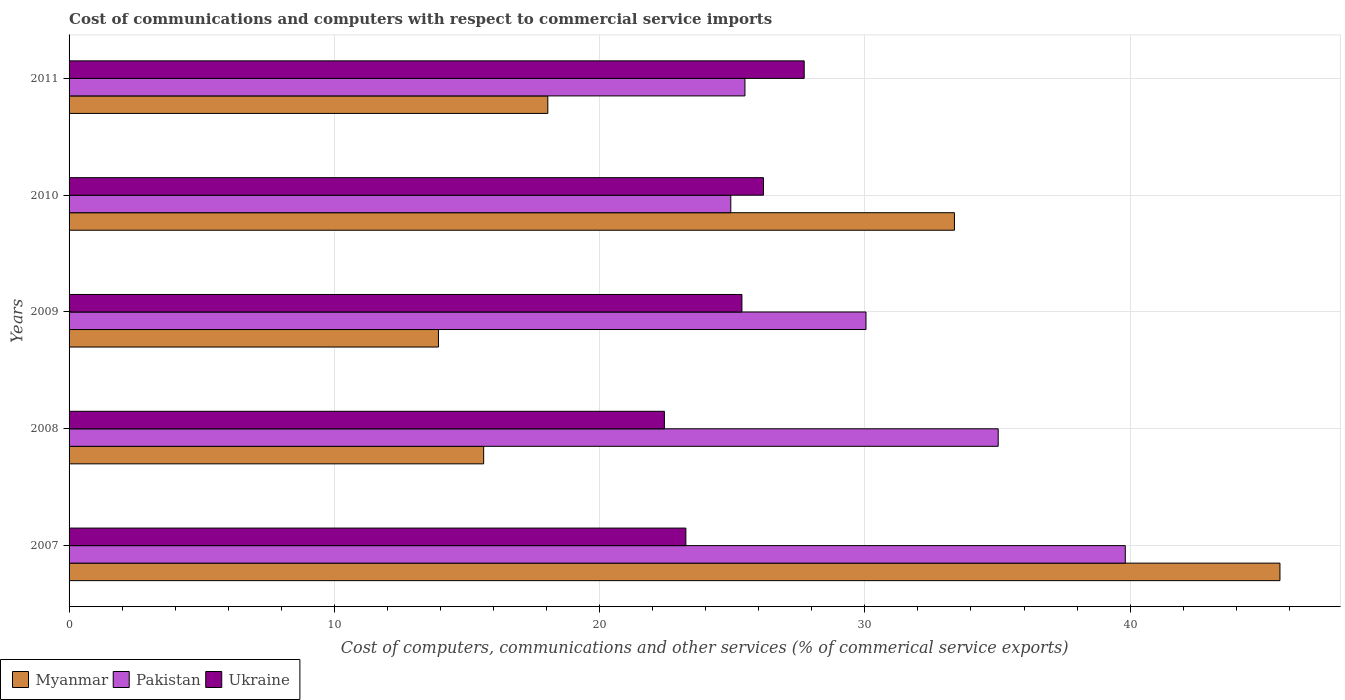What is the label of the 2nd group of bars from the top?
Your response must be concise. 2010. In how many cases, is the number of bars for a given year not equal to the number of legend labels?
Ensure brevity in your answer.  0. What is the cost of communications and computers in Ukraine in 2007?
Make the answer very short. 23.25. Across all years, what is the maximum cost of communications and computers in Myanmar?
Offer a very short reply. 45.65. Across all years, what is the minimum cost of communications and computers in Myanmar?
Provide a short and direct response. 13.93. In which year was the cost of communications and computers in Myanmar minimum?
Ensure brevity in your answer.  2009. What is the total cost of communications and computers in Ukraine in the graph?
Make the answer very short. 124.96. What is the difference between the cost of communications and computers in Pakistan in 2009 and that in 2010?
Give a very brief answer. 5.1. What is the difference between the cost of communications and computers in Myanmar in 2010 and the cost of communications and computers in Ukraine in 2007?
Provide a short and direct response. 10.12. What is the average cost of communications and computers in Pakistan per year?
Provide a succinct answer. 31.06. In the year 2007, what is the difference between the cost of communications and computers in Myanmar and cost of communications and computers in Ukraine?
Make the answer very short. 22.4. In how many years, is the cost of communications and computers in Pakistan greater than 30 %?
Your response must be concise. 3. What is the ratio of the cost of communications and computers in Myanmar in 2008 to that in 2011?
Make the answer very short. 0.87. Is the cost of communications and computers in Pakistan in 2008 less than that in 2011?
Provide a succinct answer. No. What is the difference between the highest and the second highest cost of communications and computers in Pakistan?
Provide a short and direct response. 4.79. What is the difference between the highest and the lowest cost of communications and computers in Myanmar?
Make the answer very short. 31.72. In how many years, is the cost of communications and computers in Pakistan greater than the average cost of communications and computers in Pakistan taken over all years?
Your answer should be very brief. 2. What does the 3rd bar from the top in 2011 represents?
Your answer should be very brief. Myanmar. Does the graph contain any zero values?
Give a very brief answer. No. Does the graph contain grids?
Your answer should be very brief. Yes. How many legend labels are there?
Ensure brevity in your answer.  3. How are the legend labels stacked?
Give a very brief answer. Horizontal. What is the title of the graph?
Keep it short and to the point. Cost of communications and computers with respect to commercial service imports. Does "Middle East & North Africa (all income levels)" appear as one of the legend labels in the graph?
Offer a very short reply. No. What is the label or title of the X-axis?
Your response must be concise. Cost of computers, communications and other services (% of commerical service exports). What is the Cost of computers, communications and other services (% of commerical service exports) of Myanmar in 2007?
Offer a terse response. 45.65. What is the Cost of computers, communications and other services (% of commerical service exports) in Pakistan in 2007?
Keep it short and to the point. 39.82. What is the Cost of computers, communications and other services (% of commerical service exports) of Ukraine in 2007?
Offer a very short reply. 23.25. What is the Cost of computers, communications and other services (% of commerical service exports) in Myanmar in 2008?
Give a very brief answer. 15.63. What is the Cost of computers, communications and other services (% of commerical service exports) of Pakistan in 2008?
Give a very brief answer. 35.03. What is the Cost of computers, communications and other services (% of commerical service exports) of Ukraine in 2008?
Offer a very short reply. 22.44. What is the Cost of computers, communications and other services (% of commerical service exports) in Myanmar in 2009?
Offer a very short reply. 13.93. What is the Cost of computers, communications and other services (% of commerical service exports) of Pakistan in 2009?
Ensure brevity in your answer.  30.04. What is the Cost of computers, communications and other services (% of commerical service exports) in Ukraine in 2009?
Your answer should be compact. 25.37. What is the Cost of computers, communications and other services (% of commerical service exports) in Myanmar in 2010?
Offer a terse response. 33.38. What is the Cost of computers, communications and other services (% of commerical service exports) in Pakistan in 2010?
Your answer should be very brief. 24.95. What is the Cost of computers, communications and other services (% of commerical service exports) in Ukraine in 2010?
Keep it short and to the point. 26.18. What is the Cost of computers, communications and other services (% of commerical service exports) of Myanmar in 2011?
Your answer should be very brief. 18.05. What is the Cost of computers, communications and other services (% of commerical service exports) in Pakistan in 2011?
Keep it short and to the point. 25.48. What is the Cost of computers, communications and other services (% of commerical service exports) in Ukraine in 2011?
Your answer should be very brief. 27.71. Across all years, what is the maximum Cost of computers, communications and other services (% of commerical service exports) of Myanmar?
Provide a short and direct response. 45.65. Across all years, what is the maximum Cost of computers, communications and other services (% of commerical service exports) in Pakistan?
Provide a succinct answer. 39.82. Across all years, what is the maximum Cost of computers, communications and other services (% of commerical service exports) of Ukraine?
Provide a short and direct response. 27.71. Across all years, what is the minimum Cost of computers, communications and other services (% of commerical service exports) in Myanmar?
Provide a short and direct response. 13.93. Across all years, what is the minimum Cost of computers, communications and other services (% of commerical service exports) in Pakistan?
Make the answer very short. 24.95. Across all years, what is the minimum Cost of computers, communications and other services (% of commerical service exports) of Ukraine?
Your response must be concise. 22.44. What is the total Cost of computers, communications and other services (% of commerical service exports) in Myanmar in the graph?
Offer a terse response. 126.63. What is the total Cost of computers, communications and other services (% of commerical service exports) of Pakistan in the graph?
Your answer should be compact. 155.32. What is the total Cost of computers, communications and other services (% of commerical service exports) of Ukraine in the graph?
Your response must be concise. 124.96. What is the difference between the Cost of computers, communications and other services (% of commerical service exports) in Myanmar in 2007 and that in 2008?
Provide a succinct answer. 30.02. What is the difference between the Cost of computers, communications and other services (% of commerical service exports) of Pakistan in 2007 and that in 2008?
Your answer should be very brief. 4.79. What is the difference between the Cost of computers, communications and other services (% of commerical service exports) in Ukraine in 2007 and that in 2008?
Your response must be concise. 0.81. What is the difference between the Cost of computers, communications and other services (% of commerical service exports) of Myanmar in 2007 and that in 2009?
Offer a very short reply. 31.72. What is the difference between the Cost of computers, communications and other services (% of commerical service exports) in Pakistan in 2007 and that in 2009?
Provide a succinct answer. 9.78. What is the difference between the Cost of computers, communications and other services (% of commerical service exports) in Ukraine in 2007 and that in 2009?
Your answer should be compact. -2.11. What is the difference between the Cost of computers, communications and other services (% of commerical service exports) in Myanmar in 2007 and that in 2010?
Your response must be concise. 12.27. What is the difference between the Cost of computers, communications and other services (% of commerical service exports) of Pakistan in 2007 and that in 2010?
Make the answer very short. 14.87. What is the difference between the Cost of computers, communications and other services (% of commerical service exports) of Ukraine in 2007 and that in 2010?
Make the answer very short. -2.93. What is the difference between the Cost of computers, communications and other services (% of commerical service exports) of Myanmar in 2007 and that in 2011?
Offer a very short reply. 27.6. What is the difference between the Cost of computers, communications and other services (% of commerical service exports) in Pakistan in 2007 and that in 2011?
Your response must be concise. 14.34. What is the difference between the Cost of computers, communications and other services (% of commerical service exports) of Ukraine in 2007 and that in 2011?
Ensure brevity in your answer.  -4.46. What is the difference between the Cost of computers, communications and other services (% of commerical service exports) of Myanmar in 2008 and that in 2009?
Your response must be concise. 1.7. What is the difference between the Cost of computers, communications and other services (% of commerical service exports) in Pakistan in 2008 and that in 2009?
Your answer should be very brief. 4.98. What is the difference between the Cost of computers, communications and other services (% of commerical service exports) of Ukraine in 2008 and that in 2009?
Ensure brevity in your answer.  -2.92. What is the difference between the Cost of computers, communications and other services (% of commerical service exports) in Myanmar in 2008 and that in 2010?
Provide a succinct answer. -17.75. What is the difference between the Cost of computers, communications and other services (% of commerical service exports) in Pakistan in 2008 and that in 2010?
Provide a succinct answer. 10.08. What is the difference between the Cost of computers, communications and other services (% of commerical service exports) of Ukraine in 2008 and that in 2010?
Provide a succinct answer. -3.74. What is the difference between the Cost of computers, communications and other services (% of commerical service exports) of Myanmar in 2008 and that in 2011?
Provide a succinct answer. -2.42. What is the difference between the Cost of computers, communications and other services (% of commerical service exports) of Pakistan in 2008 and that in 2011?
Your answer should be very brief. 9.55. What is the difference between the Cost of computers, communications and other services (% of commerical service exports) of Ukraine in 2008 and that in 2011?
Your answer should be compact. -5.27. What is the difference between the Cost of computers, communications and other services (% of commerical service exports) of Myanmar in 2009 and that in 2010?
Offer a very short reply. -19.45. What is the difference between the Cost of computers, communications and other services (% of commerical service exports) of Pakistan in 2009 and that in 2010?
Provide a succinct answer. 5.1. What is the difference between the Cost of computers, communications and other services (% of commerical service exports) of Ukraine in 2009 and that in 2010?
Give a very brief answer. -0.81. What is the difference between the Cost of computers, communications and other services (% of commerical service exports) in Myanmar in 2009 and that in 2011?
Ensure brevity in your answer.  -4.12. What is the difference between the Cost of computers, communications and other services (% of commerical service exports) of Pakistan in 2009 and that in 2011?
Ensure brevity in your answer.  4.56. What is the difference between the Cost of computers, communications and other services (% of commerical service exports) of Ukraine in 2009 and that in 2011?
Give a very brief answer. -2.35. What is the difference between the Cost of computers, communications and other services (% of commerical service exports) of Myanmar in 2010 and that in 2011?
Your answer should be compact. 15.33. What is the difference between the Cost of computers, communications and other services (% of commerical service exports) in Pakistan in 2010 and that in 2011?
Your answer should be compact. -0.53. What is the difference between the Cost of computers, communications and other services (% of commerical service exports) of Ukraine in 2010 and that in 2011?
Provide a succinct answer. -1.53. What is the difference between the Cost of computers, communications and other services (% of commerical service exports) in Myanmar in 2007 and the Cost of computers, communications and other services (% of commerical service exports) in Pakistan in 2008?
Provide a short and direct response. 10.62. What is the difference between the Cost of computers, communications and other services (% of commerical service exports) in Myanmar in 2007 and the Cost of computers, communications and other services (% of commerical service exports) in Ukraine in 2008?
Offer a very short reply. 23.21. What is the difference between the Cost of computers, communications and other services (% of commerical service exports) in Pakistan in 2007 and the Cost of computers, communications and other services (% of commerical service exports) in Ukraine in 2008?
Keep it short and to the point. 17.38. What is the difference between the Cost of computers, communications and other services (% of commerical service exports) in Myanmar in 2007 and the Cost of computers, communications and other services (% of commerical service exports) in Pakistan in 2009?
Give a very brief answer. 15.61. What is the difference between the Cost of computers, communications and other services (% of commerical service exports) of Myanmar in 2007 and the Cost of computers, communications and other services (% of commerical service exports) of Ukraine in 2009?
Keep it short and to the point. 20.28. What is the difference between the Cost of computers, communications and other services (% of commerical service exports) in Pakistan in 2007 and the Cost of computers, communications and other services (% of commerical service exports) in Ukraine in 2009?
Your response must be concise. 14.45. What is the difference between the Cost of computers, communications and other services (% of commerical service exports) in Myanmar in 2007 and the Cost of computers, communications and other services (% of commerical service exports) in Pakistan in 2010?
Your answer should be compact. 20.7. What is the difference between the Cost of computers, communications and other services (% of commerical service exports) of Myanmar in 2007 and the Cost of computers, communications and other services (% of commerical service exports) of Ukraine in 2010?
Provide a short and direct response. 19.47. What is the difference between the Cost of computers, communications and other services (% of commerical service exports) of Pakistan in 2007 and the Cost of computers, communications and other services (% of commerical service exports) of Ukraine in 2010?
Keep it short and to the point. 13.64. What is the difference between the Cost of computers, communications and other services (% of commerical service exports) of Myanmar in 2007 and the Cost of computers, communications and other services (% of commerical service exports) of Pakistan in 2011?
Your response must be concise. 20.17. What is the difference between the Cost of computers, communications and other services (% of commerical service exports) in Myanmar in 2007 and the Cost of computers, communications and other services (% of commerical service exports) in Ukraine in 2011?
Your response must be concise. 17.94. What is the difference between the Cost of computers, communications and other services (% of commerical service exports) in Pakistan in 2007 and the Cost of computers, communications and other services (% of commerical service exports) in Ukraine in 2011?
Offer a terse response. 12.11. What is the difference between the Cost of computers, communications and other services (% of commerical service exports) in Myanmar in 2008 and the Cost of computers, communications and other services (% of commerical service exports) in Pakistan in 2009?
Offer a terse response. -14.41. What is the difference between the Cost of computers, communications and other services (% of commerical service exports) of Myanmar in 2008 and the Cost of computers, communications and other services (% of commerical service exports) of Ukraine in 2009?
Your answer should be very brief. -9.74. What is the difference between the Cost of computers, communications and other services (% of commerical service exports) in Pakistan in 2008 and the Cost of computers, communications and other services (% of commerical service exports) in Ukraine in 2009?
Make the answer very short. 9.66. What is the difference between the Cost of computers, communications and other services (% of commerical service exports) of Myanmar in 2008 and the Cost of computers, communications and other services (% of commerical service exports) of Pakistan in 2010?
Provide a short and direct response. -9.32. What is the difference between the Cost of computers, communications and other services (% of commerical service exports) of Myanmar in 2008 and the Cost of computers, communications and other services (% of commerical service exports) of Ukraine in 2010?
Provide a succinct answer. -10.55. What is the difference between the Cost of computers, communications and other services (% of commerical service exports) in Pakistan in 2008 and the Cost of computers, communications and other services (% of commerical service exports) in Ukraine in 2010?
Make the answer very short. 8.85. What is the difference between the Cost of computers, communications and other services (% of commerical service exports) of Myanmar in 2008 and the Cost of computers, communications and other services (% of commerical service exports) of Pakistan in 2011?
Your answer should be compact. -9.85. What is the difference between the Cost of computers, communications and other services (% of commerical service exports) in Myanmar in 2008 and the Cost of computers, communications and other services (% of commerical service exports) in Ukraine in 2011?
Make the answer very short. -12.08. What is the difference between the Cost of computers, communications and other services (% of commerical service exports) in Pakistan in 2008 and the Cost of computers, communications and other services (% of commerical service exports) in Ukraine in 2011?
Your answer should be very brief. 7.31. What is the difference between the Cost of computers, communications and other services (% of commerical service exports) of Myanmar in 2009 and the Cost of computers, communications and other services (% of commerical service exports) of Pakistan in 2010?
Your answer should be very brief. -11.02. What is the difference between the Cost of computers, communications and other services (% of commerical service exports) in Myanmar in 2009 and the Cost of computers, communications and other services (% of commerical service exports) in Ukraine in 2010?
Your answer should be compact. -12.25. What is the difference between the Cost of computers, communications and other services (% of commerical service exports) of Pakistan in 2009 and the Cost of computers, communications and other services (% of commerical service exports) of Ukraine in 2010?
Provide a succinct answer. 3.86. What is the difference between the Cost of computers, communications and other services (% of commerical service exports) of Myanmar in 2009 and the Cost of computers, communications and other services (% of commerical service exports) of Pakistan in 2011?
Provide a short and direct response. -11.55. What is the difference between the Cost of computers, communications and other services (% of commerical service exports) in Myanmar in 2009 and the Cost of computers, communications and other services (% of commerical service exports) in Ukraine in 2011?
Provide a short and direct response. -13.79. What is the difference between the Cost of computers, communications and other services (% of commerical service exports) of Pakistan in 2009 and the Cost of computers, communications and other services (% of commerical service exports) of Ukraine in 2011?
Give a very brief answer. 2.33. What is the difference between the Cost of computers, communications and other services (% of commerical service exports) of Myanmar in 2010 and the Cost of computers, communications and other services (% of commerical service exports) of Pakistan in 2011?
Ensure brevity in your answer.  7.9. What is the difference between the Cost of computers, communications and other services (% of commerical service exports) in Myanmar in 2010 and the Cost of computers, communications and other services (% of commerical service exports) in Ukraine in 2011?
Give a very brief answer. 5.66. What is the difference between the Cost of computers, communications and other services (% of commerical service exports) in Pakistan in 2010 and the Cost of computers, communications and other services (% of commerical service exports) in Ukraine in 2011?
Offer a very short reply. -2.77. What is the average Cost of computers, communications and other services (% of commerical service exports) in Myanmar per year?
Offer a very short reply. 25.33. What is the average Cost of computers, communications and other services (% of commerical service exports) in Pakistan per year?
Offer a terse response. 31.06. What is the average Cost of computers, communications and other services (% of commerical service exports) of Ukraine per year?
Offer a terse response. 24.99. In the year 2007, what is the difference between the Cost of computers, communications and other services (% of commerical service exports) in Myanmar and Cost of computers, communications and other services (% of commerical service exports) in Pakistan?
Your answer should be very brief. 5.83. In the year 2007, what is the difference between the Cost of computers, communications and other services (% of commerical service exports) of Myanmar and Cost of computers, communications and other services (% of commerical service exports) of Ukraine?
Make the answer very short. 22.4. In the year 2007, what is the difference between the Cost of computers, communications and other services (% of commerical service exports) of Pakistan and Cost of computers, communications and other services (% of commerical service exports) of Ukraine?
Your answer should be compact. 16.57. In the year 2008, what is the difference between the Cost of computers, communications and other services (% of commerical service exports) in Myanmar and Cost of computers, communications and other services (% of commerical service exports) in Pakistan?
Make the answer very short. -19.4. In the year 2008, what is the difference between the Cost of computers, communications and other services (% of commerical service exports) in Myanmar and Cost of computers, communications and other services (% of commerical service exports) in Ukraine?
Your answer should be very brief. -6.81. In the year 2008, what is the difference between the Cost of computers, communications and other services (% of commerical service exports) in Pakistan and Cost of computers, communications and other services (% of commerical service exports) in Ukraine?
Your answer should be very brief. 12.58. In the year 2009, what is the difference between the Cost of computers, communications and other services (% of commerical service exports) in Myanmar and Cost of computers, communications and other services (% of commerical service exports) in Pakistan?
Offer a terse response. -16.12. In the year 2009, what is the difference between the Cost of computers, communications and other services (% of commerical service exports) in Myanmar and Cost of computers, communications and other services (% of commerical service exports) in Ukraine?
Your answer should be very brief. -11.44. In the year 2009, what is the difference between the Cost of computers, communications and other services (% of commerical service exports) of Pakistan and Cost of computers, communications and other services (% of commerical service exports) of Ukraine?
Provide a succinct answer. 4.68. In the year 2010, what is the difference between the Cost of computers, communications and other services (% of commerical service exports) in Myanmar and Cost of computers, communications and other services (% of commerical service exports) in Pakistan?
Your answer should be compact. 8.43. In the year 2010, what is the difference between the Cost of computers, communications and other services (% of commerical service exports) in Myanmar and Cost of computers, communications and other services (% of commerical service exports) in Ukraine?
Offer a terse response. 7.2. In the year 2010, what is the difference between the Cost of computers, communications and other services (% of commerical service exports) in Pakistan and Cost of computers, communications and other services (% of commerical service exports) in Ukraine?
Your answer should be compact. -1.23. In the year 2011, what is the difference between the Cost of computers, communications and other services (% of commerical service exports) of Myanmar and Cost of computers, communications and other services (% of commerical service exports) of Pakistan?
Make the answer very short. -7.43. In the year 2011, what is the difference between the Cost of computers, communications and other services (% of commerical service exports) in Myanmar and Cost of computers, communications and other services (% of commerical service exports) in Ukraine?
Give a very brief answer. -9.67. In the year 2011, what is the difference between the Cost of computers, communications and other services (% of commerical service exports) of Pakistan and Cost of computers, communications and other services (% of commerical service exports) of Ukraine?
Your response must be concise. -2.23. What is the ratio of the Cost of computers, communications and other services (% of commerical service exports) in Myanmar in 2007 to that in 2008?
Your response must be concise. 2.92. What is the ratio of the Cost of computers, communications and other services (% of commerical service exports) of Pakistan in 2007 to that in 2008?
Offer a very short reply. 1.14. What is the ratio of the Cost of computers, communications and other services (% of commerical service exports) of Ukraine in 2007 to that in 2008?
Your response must be concise. 1.04. What is the ratio of the Cost of computers, communications and other services (% of commerical service exports) of Myanmar in 2007 to that in 2009?
Keep it short and to the point. 3.28. What is the ratio of the Cost of computers, communications and other services (% of commerical service exports) of Pakistan in 2007 to that in 2009?
Your response must be concise. 1.33. What is the ratio of the Cost of computers, communications and other services (% of commerical service exports) in Myanmar in 2007 to that in 2010?
Give a very brief answer. 1.37. What is the ratio of the Cost of computers, communications and other services (% of commerical service exports) in Pakistan in 2007 to that in 2010?
Your response must be concise. 1.6. What is the ratio of the Cost of computers, communications and other services (% of commerical service exports) of Ukraine in 2007 to that in 2010?
Provide a succinct answer. 0.89. What is the ratio of the Cost of computers, communications and other services (% of commerical service exports) in Myanmar in 2007 to that in 2011?
Make the answer very short. 2.53. What is the ratio of the Cost of computers, communications and other services (% of commerical service exports) in Pakistan in 2007 to that in 2011?
Your answer should be compact. 1.56. What is the ratio of the Cost of computers, communications and other services (% of commerical service exports) in Ukraine in 2007 to that in 2011?
Your response must be concise. 0.84. What is the ratio of the Cost of computers, communications and other services (% of commerical service exports) in Myanmar in 2008 to that in 2009?
Provide a short and direct response. 1.12. What is the ratio of the Cost of computers, communications and other services (% of commerical service exports) in Pakistan in 2008 to that in 2009?
Give a very brief answer. 1.17. What is the ratio of the Cost of computers, communications and other services (% of commerical service exports) in Ukraine in 2008 to that in 2009?
Keep it short and to the point. 0.88. What is the ratio of the Cost of computers, communications and other services (% of commerical service exports) in Myanmar in 2008 to that in 2010?
Keep it short and to the point. 0.47. What is the ratio of the Cost of computers, communications and other services (% of commerical service exports) of Pakistan in 2008 to that in 2010?
Your answer should be very brief. 1.4. What is the ratio of the Cost of computers, communications and other services (% of commerical service exports) of Ukraine in 2008 to that in 2010?
Offer a terse response. 0.86. What is the ratio of the Cost of computers, communications and other services (% of commerical service exports) of Myanmar in 2008 to that in 2011?
Keep it short and to the point. 0.87. What is the ratio of the Cost of computers, communications and other services (% of commerical service exports) of Pakistan in 2008 to that in 2011?
Give a very brief answer. 1.37. What is the ratio of the Cost of computers, communications and other services (% of commerical service exports) in Ukraine in 2008 to that in 2011?
Your response must be concise. 0.81. What is the ratio of the Cost of computers, communications and other services (% of commerical service exports) in Myanmar in 2009 to that in 2010?
Your answer should be very brief. 0.42. What is the ratio of the Cost of computers, communications and other services (% of commerical service exports) of Pakistan in 2009 to that in 2010?
Provide a succinct answer. 1.2. What is the ratio of the Cost of computers, communications and other services (% of commerical service exports) in Ukraine in 2009 to that in 2010?
Your answer should be compact. 0.97. What is the ratio of the Cost of computers, communications and other services (% of commerical service exports) of Myanmar in 2009 to that in 2011?
Your response must be concise. 0.77. What is the ratio of the Cost of computers, communications and other services (% of commerical service exports) of Pakistan in 2009 to that in 2011?
Ensure brevity in your answer.  1.18. What is the ratio of the Cost of computers, communications and other services (% of commerical service exports) of Ukraine in 2009 to that in 2011?
Give a very brief answer. 0.92. What is the ratio of the Cost of computers, communications and other services (% of commerical service exports) in Myanmar in 2010 to that in 2011?
Ensure brevity in your answer.  1.85. What is the ratio of the Cost of computers, communications and other services (% of commerical service exports) in Ukraine in 2010 to that in 2011?
Ensure brevity in your answer.  0.94. What is the difference between the highest and the second highest Cost of computers, communications and other services (% of commerical service exports) in Myanmar?
Offer a very short reply. 12.27. What is the difference between the highest and the second highest Cost of computers, communications and other services (% of commerical service exports) in Pakistan?
Ensure brevity in your answer.  4.79. What is the difference between the highest and the second highest Cost of computers, communications and other services (% of commerical service exports) in Ukraine?
Your response must be concise. 1.53. What is the difference between the highest and the lowest Cost of computers, communications and other services (% of commerical service exports) of Myanmar?
Offer a very short reply. 31.72. What is the difference between the highest and the lowest Cost of computers, communications and other services (% of commerical service exports) in Pakistan?
Your response must be concise. 14.87. What is the difference between the highest and the lowest Cost of computers, communications and other services (% of commerical service exports) of Ukraine?
Offer a terse response. 5.27. 